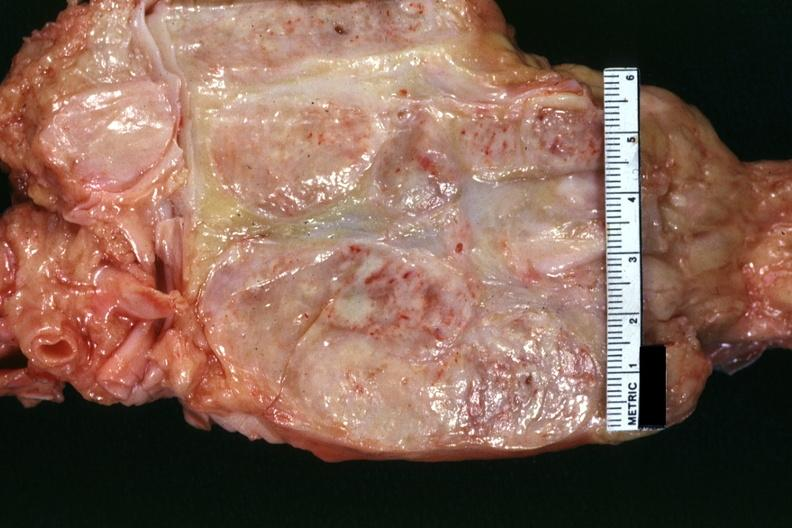what shows matting and focal necrosis?
Answer the question using a single word or phrase. Surface of nodes seen externally in slide 